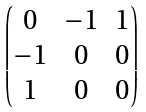Convert formula to latex. <formula><loc_0><loc_0><loc_500><loc_500>\begin{pmatrix} 0 & - 1 & 1 \\ - 1 & 0 & 0 \\ 1 & 0 & 0 \end{pmatrix}</formula> 